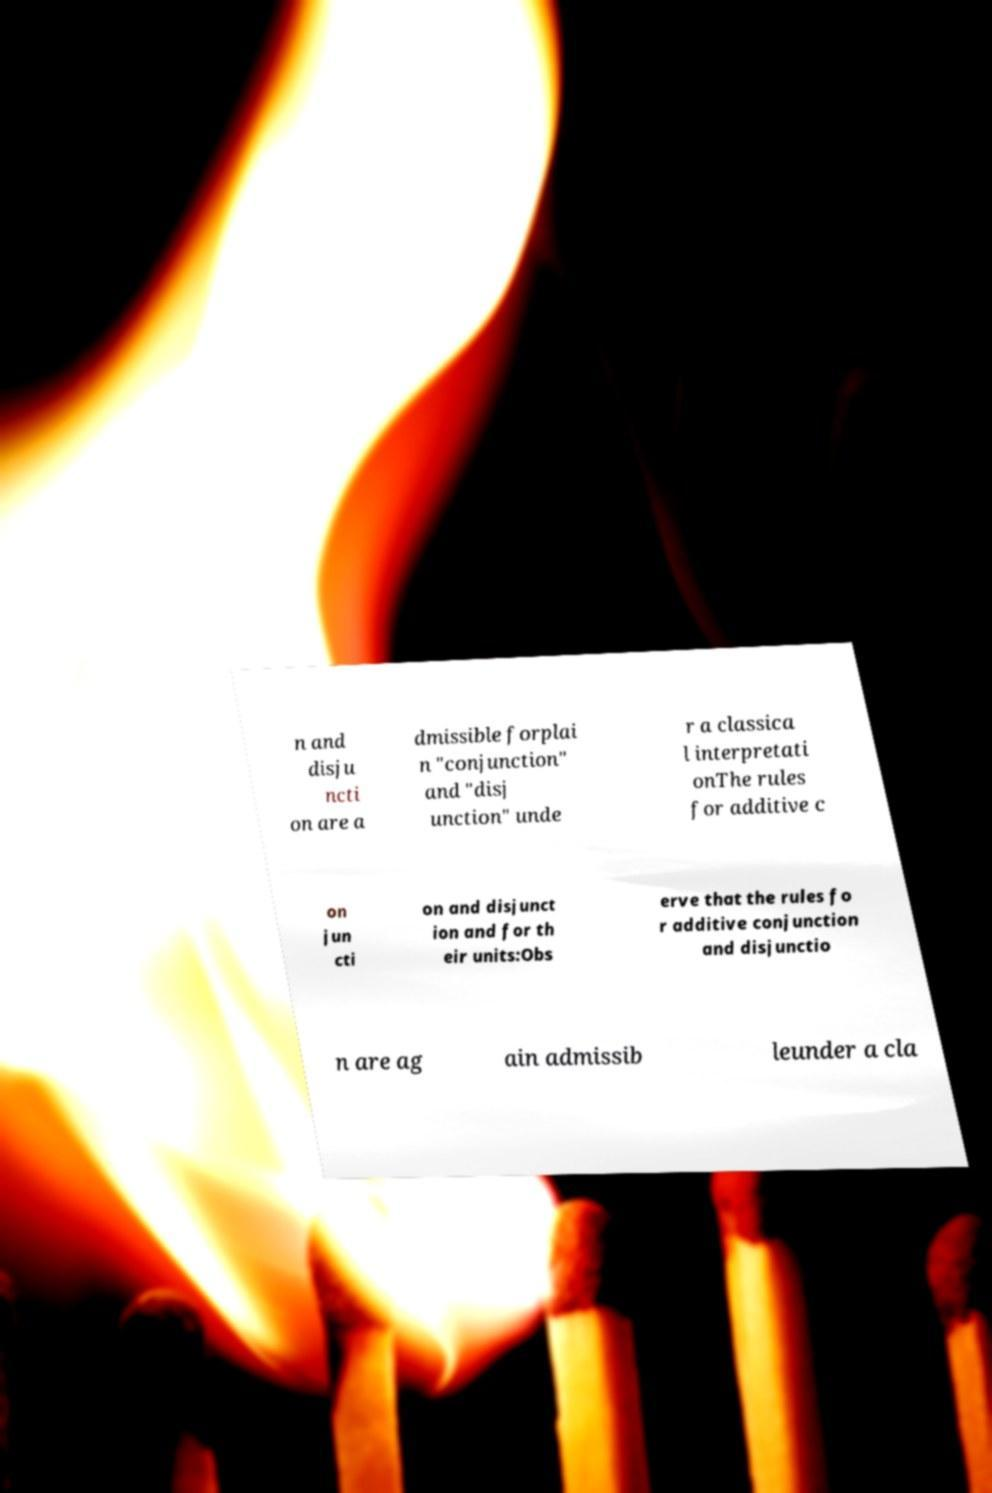Please read and relay the text visible in this image. What does it say? n and disju ncti on are a dmissible forplai n "conjunction" and "disj unction" unde r a classica l interpretati onThe rules for additive c on jun cti on and disjunct ion and for th eir units:Obs erve that the rules fo r additive conjunction and disjunctio n are ag ain admissib leunder a cla 